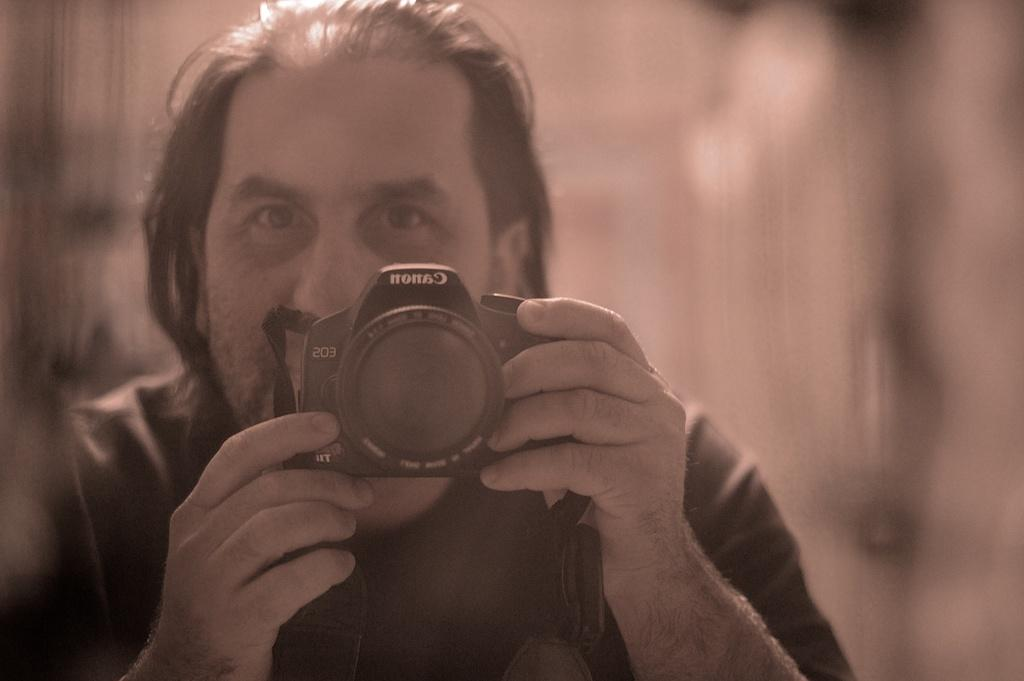Who is the main subject in the image? There is a man in the image. What is the man holding in the image? The man is holding a camera. What is the man doing with the camera? The man is taking a photograph. Can you describe the background of the image? The background of the image is blurred. What type of finger can be seen holding the cup in the image? There is no cup or finger present in the image. What kind of root is growing near the man in the image? There is no root visible in the image; it features a man holding a camera and taking a photograph with a blurred background. 